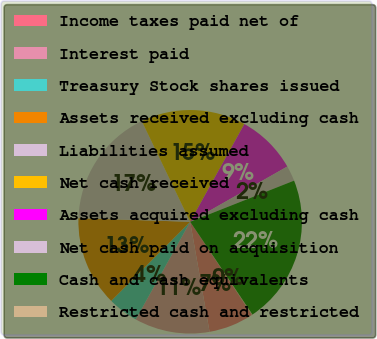<chart> <loc_0><loc_0><loc_500><loc_500><pie_chart><fcel>Income taxes paid net of<fcel>Interest paid<fcel>Treasury Stock shares issued<fcel>Assets received excluding cash<fcel>Liabilities assumed<fcel>Net cash received<fcel>Assets acquired excluding cash<fcel>Net cash paid on acquisition<fcel>Cash and cash equivalents<fcel>Restricted cash and restricted<nl><fcel>6.55%<fcel>10.87%<fcel>4.39%<fcel>13.03%<fcel>17.35%<fcel>15.19%<fcel>8.71%<fcel>2.23%<fcel>21.6%<fcel>0.07%<nl></chart> 